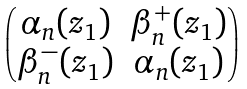<formula> <loc_0><loc_0><loc_500><loc_500>\begin{pmatrix} \alpha _ { n } ( z _ { 1 } ) & \beta _ { n } ^ { + } ( z _ { 1 } ) \\ \beta _ { n } ^ { - } ( z _ { 1 } ) & \alpha _ { n } ( z _ { 1 } ) \end{pmatrix}</formula> 